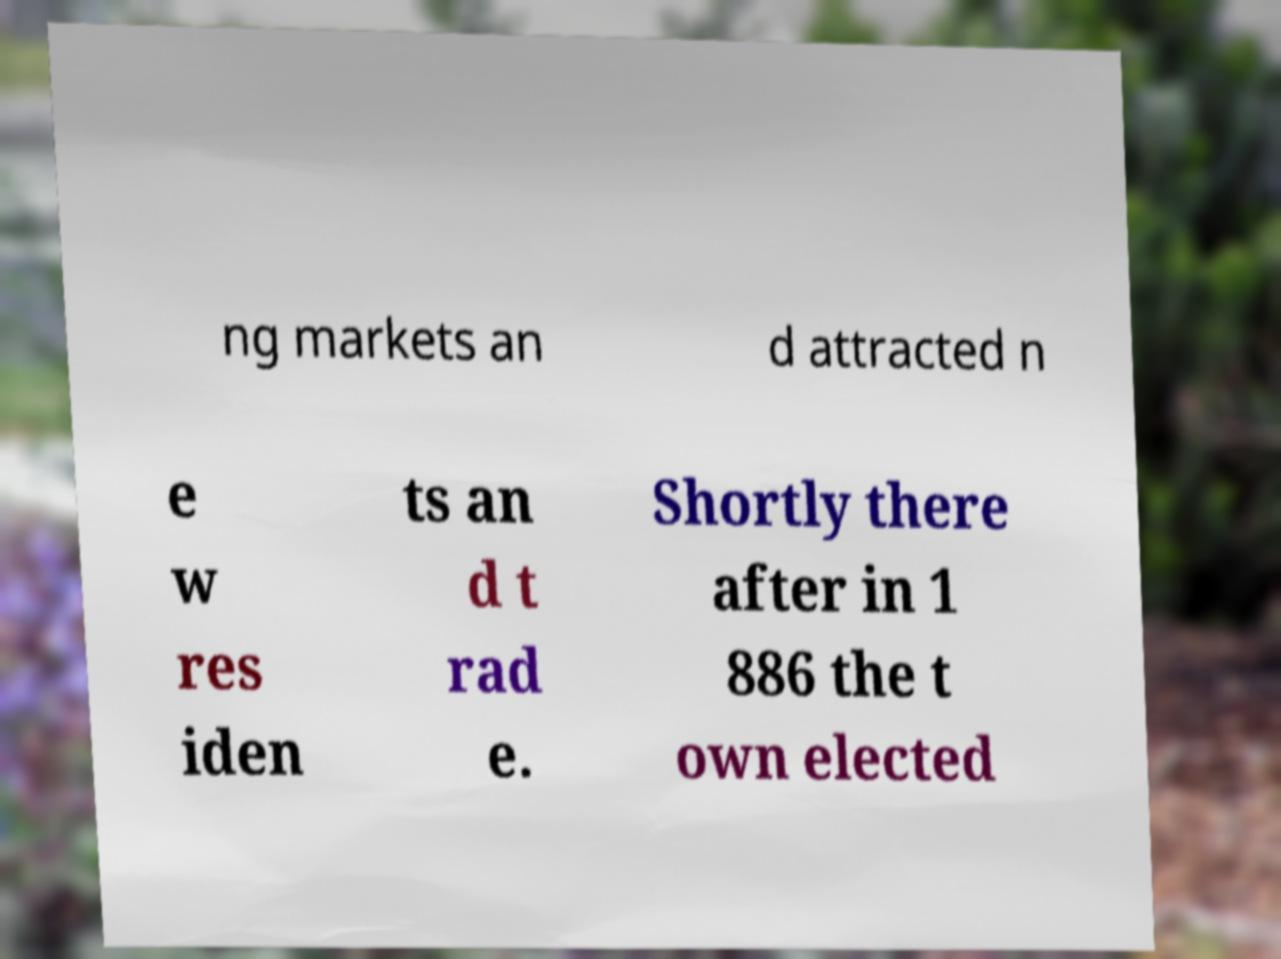For documentation purposes, I need the text within this image transcribed. Could you provide that? ng markets an d attracted n e w res iden ts an d t rad e. Shortly there after in 1 886 the t own elected 